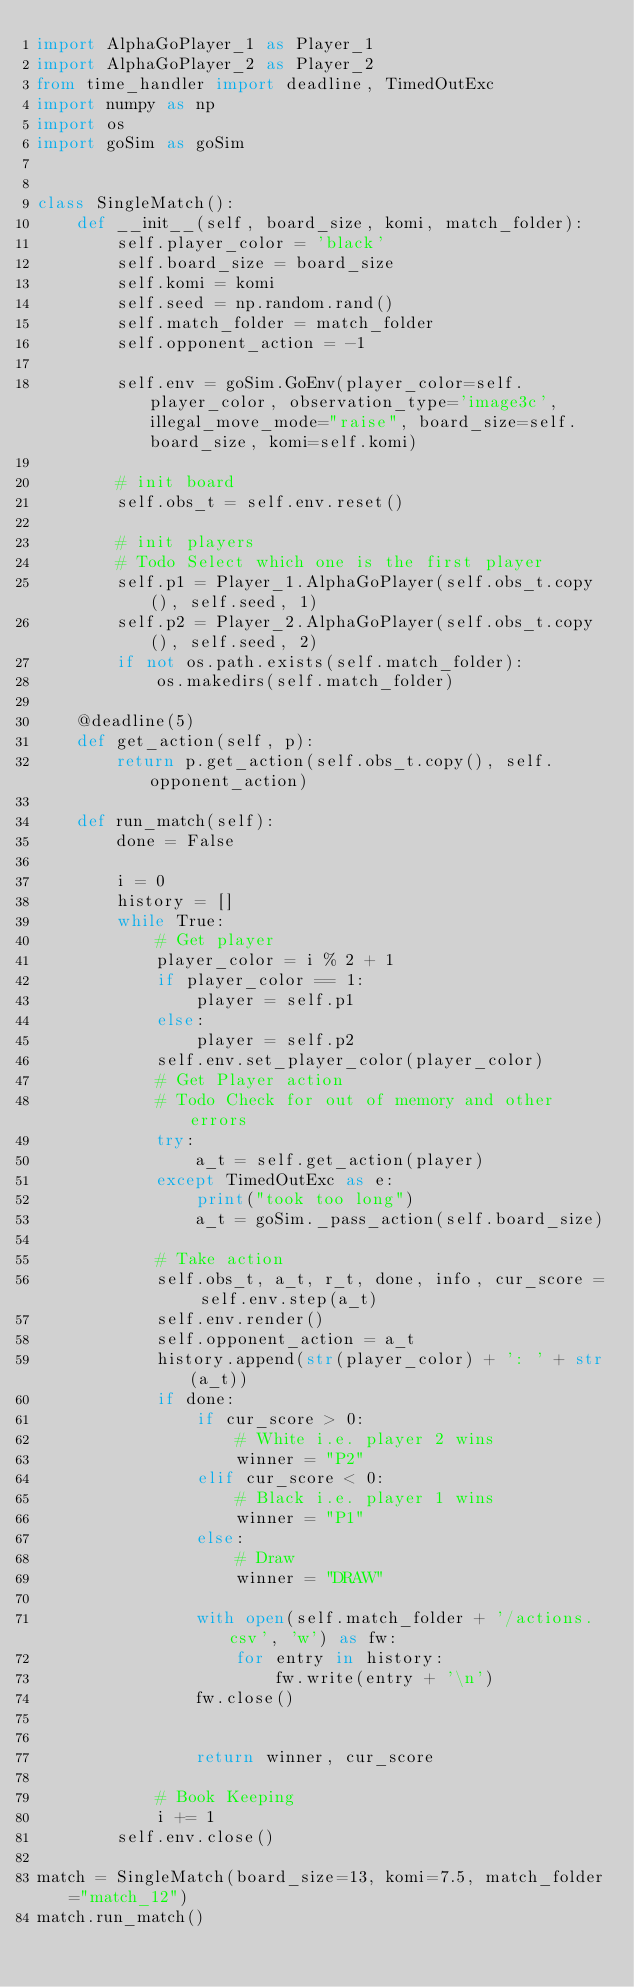Convert code to text. <code><loc_0><loc_0><loc_500><loc_500><_Python_>import AlphaGoPlayer_1 as Player_1
import AlphaGoPlayer_2 as Player_2
from time_handler import deadline, TimedOutExc
import numpy as np
import os
import goSim as goSim


class SingleMatch():
    def __init__(self, board_size, komi, match_folder):
        self.player_color = 'black'
        self.board_size = board_size
        self.komi = komi
        self.seed = np.random.rand()
        self.match_folder = match_folder
        self.opponent_action = -1

        self.env = goSim.GoEnv(player_color=self.player_color, observation_type='image3c', illegal_move_mode="raise", board_size=self.board_size, komi=self.komi)

        # init board
        self.obs_t = self.env.reset()

        # init players
        # Todo Select which one is the first player
        self.p1 = Player_1.AlphaGoPlayer(self.obs_t.copy(), self.seed, 1)
        self.p2 = Player_2.AlphaGoPlayer(self.obs_t.copy(), self.seed, 2)
        if not os.path.exists(self.match_folder):
            os.makedirs(self.match_folder)

    @deadline(5)
    def get_action(self, p):
        return p.get_action(self.obs_t.copy(), self.opponent_action)

    def run_match(self):
        done = False

        i = 0
        history = []
        while True:
            # Get player
            player_color = i % 2 + 1
            if player_color == 1:
                player = self.p1
            else:
                player = self.p2
            self.env.set_player_color(player_color)
            # Get Player action
            # Todo Check for out of memory and other errors
            try:
                a_t = self.get_action(player)
            except TimedOutExc as e:
                print("took too long")
                a_t = goSim._pass_action(self.board_size)

            # Take action
            self.obs_t, a_t, r_t, done, info, cur_score = self.env.step(a_t)
            self.env.render()
            self.opponent_action = a_t
            history.append(str(player_color) + ': ' + str(a_t))
            if done:
                if cur_score > 0:
                    # White i.e. player 2 wins
                    winner = "P2"
                elif cur_score < 0:
                    # Black i.e. player 1 wins
                    winner = "P1"
                else:
                    # Draw
                    winner = "DRAW"

                with open(self.match_folder + '/actions.csv', 'w') as fw:
                    for entry in history:
                        fw.write(entry + '\n')
                fw.close()


                return winner, cur_score

            # Book Keeping
            i += 1
        self.env.close()
        
match = SingleMatch(board_size=13, komi=7.5, match_folder="match_12")
match.run_match()</code> 